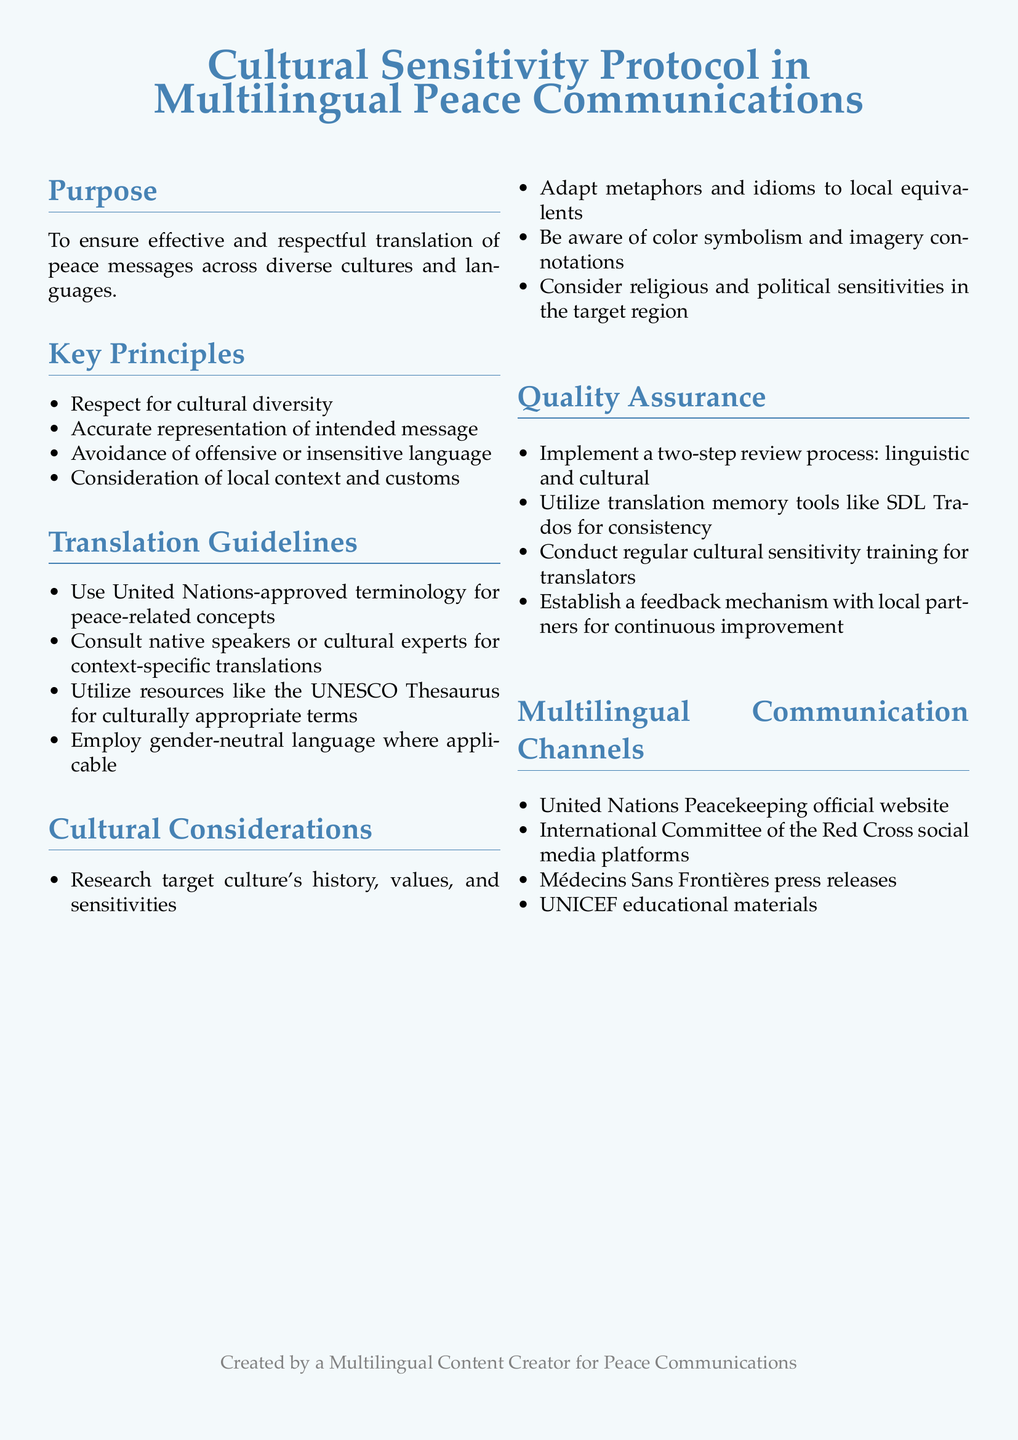What is the document's purpose? The purpose section outlines the intent of the protocol, which is to ensure effective and respectful translation of peace messages.
Answer: To ensure effective and respectful translation of peace messages across diverse cultures and languages How many key principles are listed? The key principles section enumerates specific guidelines, which total four distinct principles.
Answer: Four Which organization’s terminology should be used? The translation guidelines specify that United Nations-approved terminology is required for peace-related concepts.
Answer: United Nations What should be consulted for context-specific translations? The translation guidelines recommend consulting native speakers or experts to ensure context appropriateness.
Answer: Native speakers or cultural experts What is the first step in the quality assurance process? The quality assurance section details a two-step review process, beginning with a linguistic review.
Answer: Linguistic review According to the document, what type of language should be employed where applicable? The translation guidelines mention the importance of using gender-neutral language in translations.
Answer: Gender-neutral language What kind of training should translators undergo? The document states that cultural sensitivity training is essential for translators to improve their translation effectiveness.
Answer: Cultural sensitivity training What is one of the multilingual communication channels mentioned? The multilingual communication channels section lists specific organizations and platforms such as the United Nations Peacekeeping official website.
Answer: United Nations Peacekeeping official website 